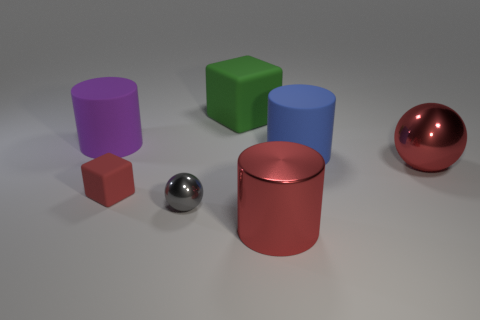What is the shape of the tiny red rubber thing?
Make the answer very short. Cube. What number of objects are either large green cubes or blue cylinders?
Give a very brief answer. 2. There is a ball to the right of the large green cube; does it have the same color as the big cylinder that is in front of the red rubber object?
Offer a very short reply. Yes. What number of other things are there of the same shape as the blue rubber thing?
Make the answer very short. 2. Are any cyan rubber spheres visible?
Your response must be concise. No. How many things are either purple objects or matte cylinders left of the tiny rubber cube?
Provide a succinct answer. 1. There is a rubber block behind the blue object; is its size the same as the big purple rubber thing?
Your answer should be very brief. Yes. How many other objects are there of the same size as the purple object?
Your answer should be compact. 4. What color is the large shiny sphere?
Make the answer very short. Red. What material is the block behind the big red metallic sphere?
Provide a succinct answer. Rubber. 